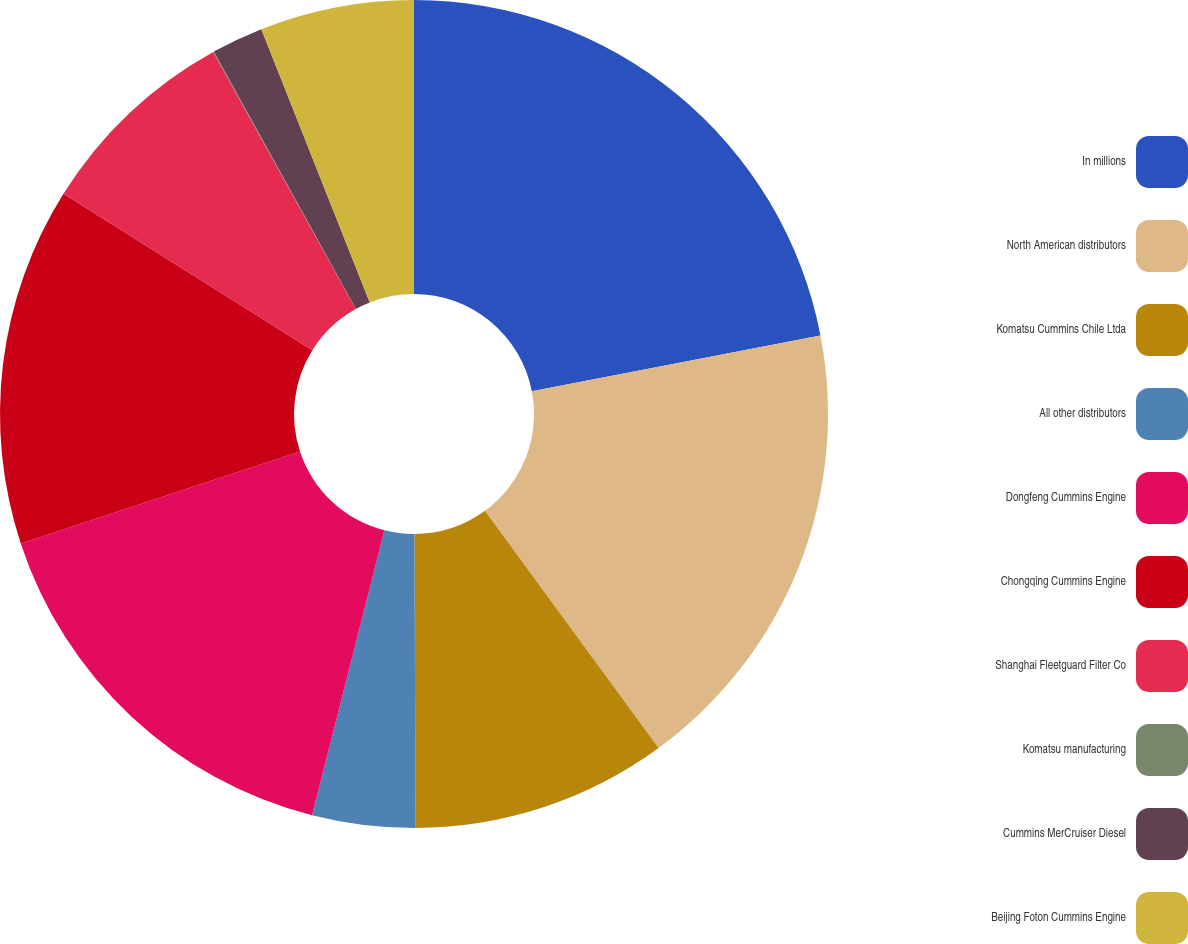Convert chart to OTSL. <chart><loc_0><loc_0><loc_500><loc_500><pie_chart><fcel>In millions<fcel>North American distributors<fcel>Komatsu Cummins Chile Ltda<fcel>All other distributors<fcel>Dongfeng Cummins Engine<fcel>Chongqing Cummins Engine<fcel>Shanghai Fleetguard Filter Co<fcel>Komatsu manufacturing<fcel>Cummins MerCruiser Diesel<fcel>Beijing Foton Cummins Engine<nl><fcel>21.96%<fcel>17.98%<fcel>10.0%<fcel>4.02%<fcel>15.98%<fcel>13.99%<fcel>8.01%<fcel>0.03%<fcel>2.02%<fcel>6.01%<nl></chart> 